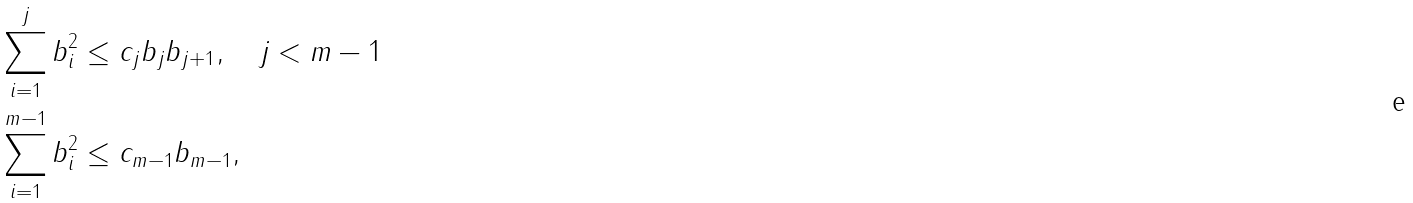<formula> <loc_0><loc_0><loc_500><loc_500>& \sum _ { i = 1 } ^ { j } b _ { i } ^ { 2 } \leq c _ { j } b _ { j } b _ { j + 1 } , \quad j < m - 1 \\ & \sum _ { i = 1 } ^ { m - 1 } b _ { i } ^ { 2 } \leq c _ { m - 1 } b _ { m - 1 } ,</formula> 